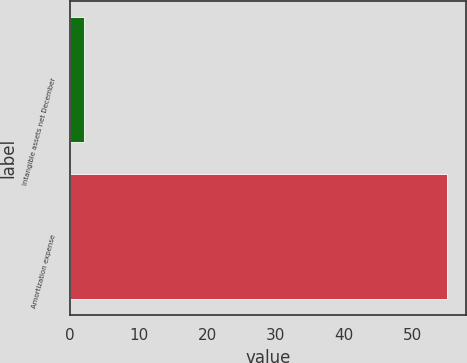Convert chart to OTSL. <chart><loc_0><loc_0><loc_500><loc_500><bar_chart><fcel>Intangible assets net December<fcel>Amortization expense<nl><fcel>2<fcel>55<nl></chart> 